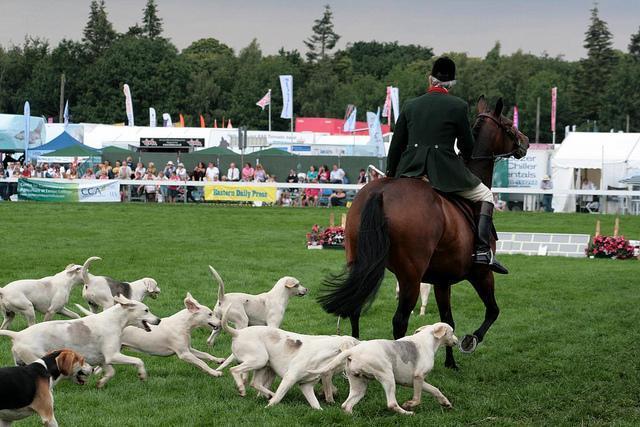How many dogs are there?
Give a very brief answer. 9. How many dogs are in the picture?
Give a very brief answer. 7. How many people are in the photo?
Give a very brief answer. 2. How many blue ties do you see?
Give a very brief answer. 0. 